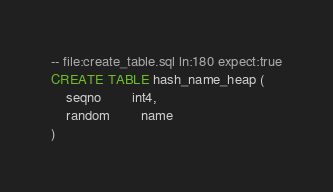<code> <loc_0><loc_0><loc_500><loc_500><_SQL_>-- file:create_table.sql ln:180 expect:true
CREATE TABLE hash_name_heap (
	seqno 		int4,
	random 		name
)
</code> 